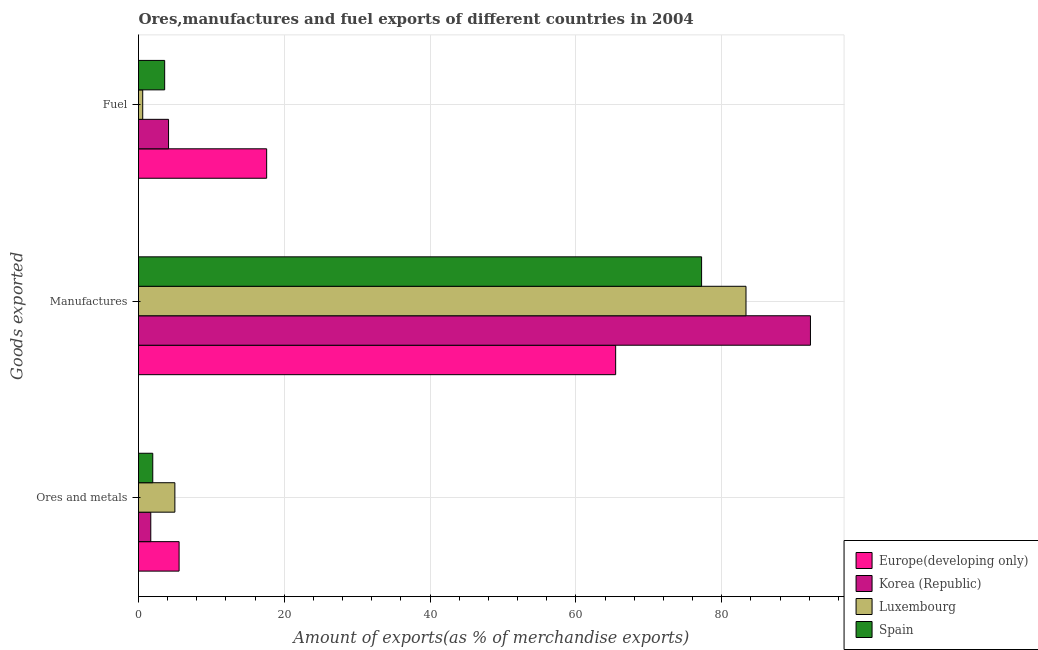How many groups of bars are there?
Provide a succinct answer. 3. Are the number of bars per tick equal to the number of legend labels?
Give a very brief answer. Yes. How many bars are there on the 2nd tick from the bottom?
Give a very brief answer. 4. What is the label of the 3rd group of bars from the top?
Offer a very short reply. Ores and metals. What is the percentage of fuel exports in Luxembourg?
Your response must be concise. 0.58. Across all countries, what is the maximum percentage of ores and metals exports?
Your answer should be compact. 5.57. Across all countries, what is the minimum percentage of fuel exports?
Provide a succinct answer. 0.58. In which country was the percentage of fuel exports minimum?
Your answer should be very brief. Luxembourg. What is the total percentage of ores and metals exports in the graph?
Your response must be concise. 14.2. What is the difference between the percentage of manufactures exports in Europe(developing only) and that in Korea (Republic)?
Your answer should be compact. -26.72. What is the difference between the percentage of ores and metals exports in Luxembourg and the percentage of manufactures exports in Korea (Republic)?
Your answer should be compact. -87.19. What is the average percentage of fuel exports per country?
Ensure brevity in your answer.  6.47. What is the difference between the percentage of fuel exports and percentage of manufactures exports in Korea (Republic)?
Make the answer very short. -88.06. In how many countries, is the percentage of manufactures exports greater than 32 %?
Your answer should be very brief. 4. What is the ratio of the percentage of ores and metals exports in Spain to that in Korea (Republic)?
Make the answer very short. 1.16. Is the difference between the percentage of manufactures exports in Spain and Europe(developing only) greater than the difference between the percentage of fuel exports in Spain and Europe(developing only)?
Keep it short and to the point. Yes. What is the difference between the highest and the second highest percentage of fuel exports?
Your answer should be compact. 13.46. What is the difference between the highest and the lowest percentage of ores and metals exports?
Keep it short and to the point. 3.89. In how many countries, is the percentage of ores and metals exports greater than the average percentage of ores and metals exports taken over all countries?
Ensure brevity in your answer.  2. Is the sum of the percentage of ores and metals exports in Korea (Republic) and Luxembourg greater than the maximum percentage of manufactures exports across all countries?
Provide a succinct answer. No. What does the 1st bar from the bottom in Fuel represents?
Make the answer very short. Europe(developing only). How many bars are there?
Keep it short and to the point. 12. Does the graph contain any zero values?
Make the answer very short. No. How many legend labels are there?
Provide a succinct answer. 4. What is the title of the graph?
Your response must be concise. Ores,manufactures and fuel exports of different countries in 2004. Does "Heavily indebted poor countries" appear as one of the legend labels in the graph?
Your answer should be very brief. No. What is the label or title of the X-axis?
Offer a terse response. Amount of exports(as % of merchandise exports). What is the label or title of the Y-axis?
Ensure brevity in your answer.  Goods exported. What is the Amount of exports(as % of merchandise exports) of Europe(developing only) in Ores and metals?
Your response must be concise. 5.57. What is the Amount of exports(as % of merchandise exports) in Korea (Republic) in Ores and metals?
Provide a succinct answer. 1.68. What is the Amount of exports(as % of merchandise exports) in Luxembourg in Ores and metals?
Your answer should be compact. 4.99. What is the Amount of exports(as % of merchandise exports) in Spain in Ores and metals?
Your response must be concise. 1.96. What is the Amount of exports(as % of merchandise exports) in Europe(developing only) in Manufactures?
Your response must be concise. 65.46. What is the Amount of exports(as % of merchandise exports) of Korea (Republic) in Manufactures?
Ensure brevity in your answer.  92.18. What is the Amount of exports(as % of merchandise exports) of Luxembourg in Manufactures?
Ensure brevity in your answer.  83.34. What is the Amount of exports(as % of merchandise exports) in Spain in Manufactures?
Offer a very short reply. 77.24. What is the Amount of exports(as % of merchandise exports) of Europe(developing only) in Fuel?
Your answer should be very brief. 17.58. What is the Amount of exports(as % of merchandise exports) of Korea (Republic) in Fuel?
Your response must be concise. 4.12. What is the Amount of exports(as % of merchandise exports) in Luxembourg in Fuel?
Ensure brevity in your answer.  0.58. What is the Amount of exports(as % of merchandise exports) of Spain in Fuel?
Provide a succinct answer. 3.59. Across all Goods exported, what is the maximum Amount of exports(as % of merchandise exports) of Europe(developing only)?
Provide a succinct answer. 65.46. Across all Goods exported, what is the maximum Amount of exports(as % of merchandise exports) of Korea (Republic)?
Offer a terse response. 92.18. Across all Goods exported, what is the maximum Amount of exports(as % of merchandise exports) in Luxembourg?
Keep it short and to the point. 83.34. Across all Goods exported, what is the maximum Amount of exports(as % of merchandise exports) in Spain?
Keep it short and to the point. 77.24. Across all Goods exported, what is the minimum Amount of exports(as % of merchandise exports) of Europe(developing only)?
Keep it short and to the point. 5.57. Across all Goods exported, what is the minimum Amount of exports(as % of merchandise exports) of Korea (Republic)?
Provide a short and direct response. 1.68. Across all Goods exported, what is the minimum Amount of exports(as % of merchandise exports) in Luxembourg?
Your response must be concise. 0.58. Across all Goods exported, what is the minimum Amount of exports(as % of merchandise exports) of Spain?
Ensure brevity in your answer.  1.96. What is the total Amount of exports(as % of merchandise exports) of Europe(developing only) in the graph?
Offer a terse response. 88.6. What is the total Amount of exports(as % of merchandise exports) in Korea (Republic) in the graph?
Make the answer very short. 97.98. What is the total Amount of exports(as % of merchandise exports) of Luxembourg in the graph?
Your response must be concise. 88.9. What is the total Amount of exports(as % of merchandise exports) in Spain in the graph?
Keep it short and to the point. 82.79. What is the difference between the Amount of exports(as % of merchandise exports) of Europe(developing only) in Ores and metals and that in Manufactures?
Make the answer very short. -59.89. What is the difference between the Amount of exports(as % of merchandise exports) in Korea (Republic) in Ores and metals and that in Manufactures?
Your response must be concise. -90.5. What is the difference between the Amount of exports(as % of merchandise exports) in Luxembourg in Ores and metals and that in Manufactures?
Give a very brief answer. -78.35. What is the difference between the Amount of exports(as % of merchandise exports) in Spain in Ores and metals and that in Manufactures?
Your answer should be very brief. -75.29. What is the difference between the Amount of exports(as % of merchandise exports) in Europe(developing only) in Ores and metals and that in Fuel?
Offer a terse response. -12.01. What is the difference between the Amount of exports(as % of merchandise exports) in Korea (Republic) in Ores and metals and that in Fuel?
Offer a very short reply. -2.44. What is the difference between the Amount of exports(as % of merchandise exports) in Luxembourg in Ores and metals and that in Fuel?
Keep it short and to the point. 4.41. What is the difference between the Amount of exports(as % of merchandise exports) of Spain in Ores and metals and that in Fuel?
Ensure brevity in your answer.  -1.63. What is the difference between the Amount of exports(as % of merchandise exports) of Europe(developing only) in Manufactures and that in Fuel?
Your answer should be very brief. 47.88. What is the difference between the Amount of exports(as % of merchandise exports) of Korea (Republic) in Manufactures and that in Fuel?
Your answer should be compact. 88.06. What is the difference between the Amount of exports(as % of merchandise exports) of Luxembourg in Manufactures and that in Fuel?
Make the answer very short. 82.76. What is the difference between the Amount of exports(as % of merchandise exports) of Spain in Manufactures and that in Fuel?
Make the answer very short. 73.65. What is the difference between the Amount of exports(as % of merchandise exports) of Europe(developing only) in Ores and metals and the Amount of exports(as % of merchandise exports) of Korea (Republic) in Manufactures?
Make the answer very short. -86.61. What is the difference between the Amount of exports(as % of merchandise exports) in Europe(developing only) in Ores and metals and the Amount of exports(as % of merchandise exports) in Luxembourg in Manufactures?
Offer a very short reply. -77.77. What is the difference between the Amount of exports(as % of merchandise exports) of Europe(developing only) in Ores and metals and the Amount of exports(as % of merchandise exports) of Spain in Manufactures?
Provide a succinct answer. -71.67. What is the difference between the Amount of exports(as % of merchandise exports) in Korea (Republic) in Ores and metals and the Amount of exports(as % of merchandise exports) in Luxembourg in Manufactures?
Your response must be concise. -81.65. What is the difference between the Amount of exports(as % of merchandise exports) of Korea (Republic) in Ores and metals and the Amount of exports(as % of merchandise exports) of Spain in Manufactures?
Ensure brevity in your answer.  -75.56. What is the difference between the Amount of exports(as % of merchandise exports) of Luxembourg in Ores and metals and the Amount of exports(as % of merchandise exports) of Spain in Manufactures?
Offer a terse response. -72.25. What is the difference between the Amount of exports(as % of merchandise exports) of Europe(developing only) in Ores and metals and the Amount of exports(as % of merchandise exports) of Korea (Republic) in Fuel?
Your response must be concise. 1.45. What is the difference between the Amount of exports(as % of merchandise exports) in Europe(developing only) in Ores and metals and the Amount of exports(as % of merchandise exports) in Luxembourg in Fuel?
Provide a succinct answer. 4.99. What is the difference between the Amount of exports(as % of merchandise exports) in Europe(developing only) in Ores and metals and the Amount of exports(as % of merchandise exports) in Spain in Fuel?
Provide a short and direct response. 1.98. What is the difference between the Amount of exports(as % of merchandise exports) of Korea (Republic) in Ores and metals and the Amount of exports(as % of merchandise exports) of Luxembourg in Fuel?
Offer a terse response. 1.11. What is the difference between the Amount of exports(as % of merchandise exports) in Korea (Republic) in Ores and metals and the Amount of exports(as % of merchandise exports) in Spain in Fuel?
Provide a short and direct response. -1.91. What is the difference between the Amount of exports(as % of merchandise exports) of Luxembourg in Ores and metals and the Amount of exports(as % of merchandise exports) of Spain in Fuel?
Provide a succinct answer. 1.4. What is the difference between the Amount of exports(as % of merchandise exports) of Europe(developing only) in Manufactures and the Amount of exports(as % of merchandise exports) of Korea (Republic) in Fuel?
Ensure brevity in your answer.  61.33. What is the difference between the Amount of exports(as % of merchandise exports) in Europe(developing only) in Manufactures and the Amount of exports(as % of merchandise exports) in Luxembourg in Fuel?
Keep it short and to the point. 64.88. What is the difference between the Amount of exports(as % of merchandise exports) of Europe(developing only) in Manufactures and the Amount of exports(as % of merchandise exports) of Spain in Fuel?
Your answer should be compact. 61.87. What is the difference between the Amount of exports(as % of merchandise exports) of Korea (Republic) in Manufactures and the Amount of exports(as % of merchandise exports) of Luxembourg in Fuel?
Provide a succinct answer. 91.6. What is the difference between the Amount of exports(as % of merchandise exports) of Korea (Republic) in Manufactures and the Amount of exports(as % of merchandise exports) of Spain in Fuel?
Make the answer very short. 88.59. What is the difference between the Amount of exports(as % of merchandise exports) in Luxembourg in Manufactures and the Amount of exports(as % of merchandise exports) in Spain in Fuel?
Keep it short and to the point. 79.75. What is the average Amount of exports(as % of merchandise exports) of Europe(developing only) per Goods exported?
Ensure brevity in your answer.  29.53. What is the average Amount of exports(as % of merchandise exports) in Korea (Republic) per Goods exported?
Your answer should be compact. 32.66. What is the average Amount of exports(as % of merchandise exports) in Luxembourg per Goods exported?
Make the answer very short. 29.63. What is the average Amount of exports(as % of merchandise exports) in Spain per Goods exported?
Provide a short and direct response. 27.6. What is the difference between the Amount of exports(as % of merchandise exports) in Europe(developing only) and Amount of exports(as % of merchandise exports) in Korea (Republic) in Ores and metals?
Keep it short and to the point. 3.89. What is the difference between the Amount of exports(as % of merchandise exports) of Europe(developing only) and Amount of exports(as % of merchandise exports) of Luxembourg in Ores and metals?
Make the answer very short. 0.58. What is the difference between the Amount of exports(as % of merchandise exports) of Europe(developing only) and Amount of exports(as % of merchandise exports) of Spain in Ores and metals?
Offer a very short reply. 3.61. What is the difference between the Amount of exports(as % of merchandise exports) in Korea (Republic) and Amount of exports(as % of merchandise exports) in Luxembourg in Ores and metals?
Your response must be concise. -3.31. What is the difference between the Amount of exports(as % of merchandise exports) of Korea (Republic) and Amount of exports(as % of merchandise exports) of Spain in Ores and metals?
Provide a short and direct response. -0.27. What is the difference between the Amount of exports(as % of merchandise exports) of Luxembourg and Amount of exports(as % of merchandise exports) of Spain in Ores and metals?
Your response must be concise. 3.03. What is the difference between the Amount of exports(as % of merchandise exports) of Europe(developing only) and Amount of exports(as % of merchandise exports) of Korea (Republic) in Manufactures?
Your answer should be very brief. -26.72. What is the difference between the Amount of exports(as % of merchandise exports) in Europe(developing only) and Amount of exports(as % of merchandise exports) in Luxembourg in Manufactures?
Provide a short and direct response. -17.88. What is the difference between the Amount of exports(as % of merchandise exports) of Europe(developing only) and Amount of exports(as % of merchandise exports) of Spain in Manufactures?
Keep it short and to the point. -11.79. What is the difference between the Amount of exports(as % of merchandise exports) in Korea (Republic) and Amount of exports(as % of merchandise exports) in Luxembourg in Manufactures?
Provide a short and direct response. 8.84. What is the difference between the Amount of exports(as % of merchandise exports) of Korea (Republic) and Amount of exports(as % of merchandise exports) of Spain in Manufactures?
Offer a very short reply. 14.93. What is the difference between the Amount of exports(as % of merchandise exports) of Luxembourg and Amount of exports(as % of merchandise exports) of Spain in Manufactures?
Keep it short and to the point. 6.09. What is the difference between the Amount of exports(as % of merchandise exports) in Europe(developing only) and Amount of exports(as % of merchandise exports) in Korea (Republic) in Fuel?
Keep it short and to the point. 13.46. What is the difference between the Amount of exports(as % of merchandise exports) of Europe(developing only) and Amount of exports(as % of merchandise exports) of Luxembourg in Fuel?
Keep it short and to the point. 17. What is the difference between the Amount of exports(as % of merchandise exports) in Europe(developing only) and Amount of exports(as % of merchandise exports) in Spain in Fuel?
Offer a terse response. 13.99. What is the difference between the Amount of exports(as % of merchandise exports) of Korea (Republic) and Amount of exports(as % of merchandise exports) of Luxembourg in Fuel?
Provide a succinct answer. 3.54. What is the difference between the Amount of exports(as % of merchandise exports) in Korea (Republic) and Amount of exports(as % of merchandise exports) in Spain in Fuel?
Provide a succinct answer. 0.53. What is the difference between the Amount of exports(as % of merchandise exports) of Luxembourg and Amount of exports(as % of merchandise exports) of Spain in Fuel?
Offer a very short reply. -3.01. What is the ratio of the Amount of exports(as % of merchandise exports) of Europe(developing only) in Ores and metals to that in Manufactures?
Your answer should be very brief. 0.09. What is the ratio of the Amount of exports(as % of merchandise exports) in Korea (Republic) in Ores and metals to that in Manufactures?
Provide a succinct answer. 0.02. What is the ratio of the Amount of exports(as % of merchandise exports) of Luxembourg in Ores and metals to that in Manufactures?
Make the answer very short. 0.06. What is the ratio of the Amount of exports(as % of merchandise exports) of Spain in Ores and metals to that in Manufactures?
Offer a terse response. 0.03. What is the ratio of the Amount of exports(as % of merchandise exports) of Europe(developing only) in Ores and metals to that in Fuel?
Your answer should be compact. 0.32. What is the ratio of the Amount of exports(as % of merchandise exports) in Korea (Republic) in Ores and metals to that in Fuel?
Your answer should be very brief. 0.41. What is the ratio of the Amount of exports(as % of merchandise exports) of Luxembourg in Ores and metals to that in Fuel?
Offer a very short reply. 8.65. What is the ratio of the Amount of exports(as % of merchandise exports) of Spain in Ores and metals to that in Fuel?
Offer a terse response. 0.54. What is the ratio of the Amount of exports(as % of merchandise exports) in Europe(developing only) in Manufactures to that in Fuel?
Make the answer very short. 3.72. What is the ratio of the Amount of exports(as % of merchandise exports) of Korea (Republic) in Manufactures to that in Fuel?
Offer a terse response. 22.37. What is the ratio of the Amount of exports(as % of merchandise exports) of Luxembourg in Manufactures to that in Fuel?
Keep it short and to the point. 144.52. What is the ratio of the Amount of exports(as % of merchandise exports) of Spain in Manufactures to that in Fuel?
Your response must be concise. 21.52. What is the difference between the highest and the second highest Amount of exports(as % of merchandise exports) in Europe(developing only)?
Offer a terse response. 47.88. What is the difference between the highest and the second highest Amount of exports(as % of merchandise exports) in Korea (Republic)?
Make the answer very short. 88.06. What is the difference between the highest and the second highest Amount of exports(as % of merchandise exports) in Luxembourg?
Your answer should be very brief. 78.35. What is the difference between the highest and the second highest Amount of exports(as % of merchandise exports) in Spain?
Offer a terse response. 73.65. What is the difference between the highest and the lowest Amount of exports(as % of merchandise exports) of Europe(developing only)?
Your answer should be compact. 59.89. What is the difference between the highest and the lowest Amount of exports(as % of merchandise exports) in Korea (Republic)?
Offer a very short reply. 90.5. What is the difference between the highest and the lowest Amount of exports(as % of merchandise exports) of Luxembourg?
Your response must be concise. 82.76. What is the difference between the highest and the lowest Amount of exports(as % of merchandise exports) in Spain?
Your answer should be very brief. 75.29. 